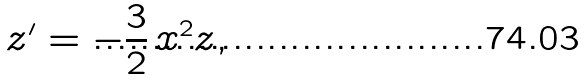Convert formula to latex. <formula><loc_0><loc_0><loc_500><loc_500>z ^ { \prime } = - \frac { 3 } { 2 } \, x ^ { 2 } z ,</formula> 